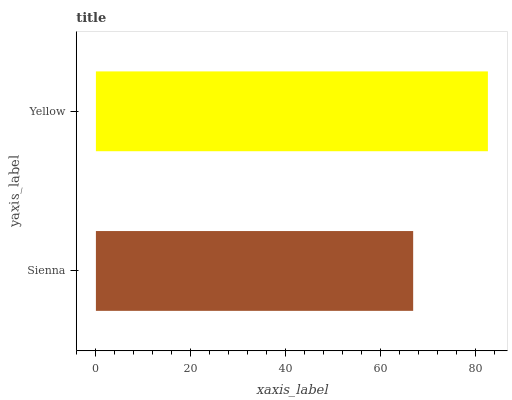Is Sienna the minimum?
Answer yes or no. Yes. Is Yellow the maximum?
Answer yes or no. Yes. Is Yellow the minimum?
Answer yes or no. No. Is Yellow greater than Sienna?
Answer yes or no. Yes. Is Sienna less than Yellow?
Answer yes or no. Yes. Is Sienna greater than Yellow?
Answer yes or no. No. Is Yellow less than Sienna?
Answer yes or no. No. Is Yellow the high median?
Answer yes or no. Yes. Is Sienna the low median?
Answer yes or no. Yes. Is Sienna the high median?
Answer yes or no. No. Is Yellow the low median?
Answer yes or no. No. 